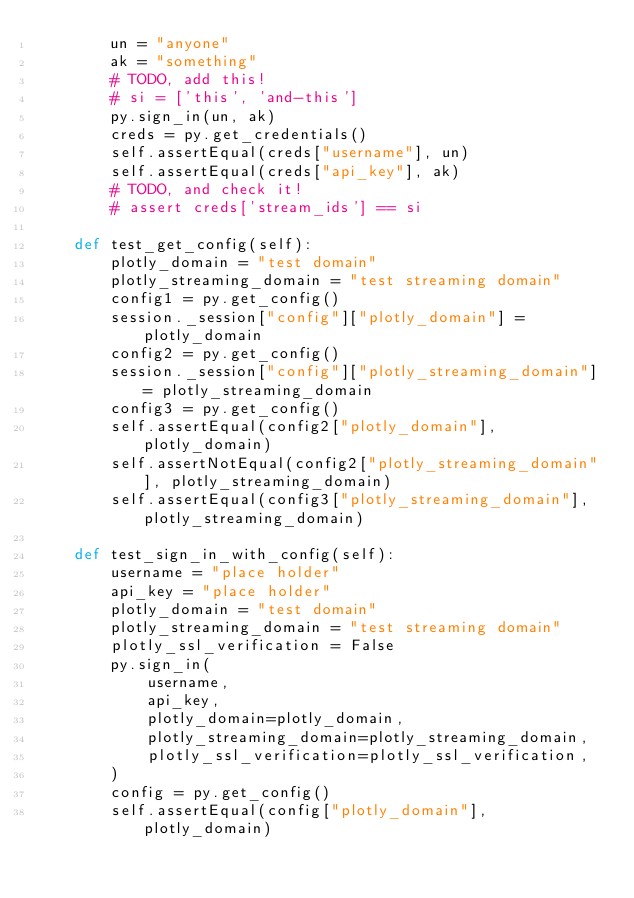<code> <loc_0><loc_0><loc_500><loc_500><_Python_>        un = "anyone"
        ak = "something"
        # TODO, add this!
        # si = ['this', 'and-this']
        py.sign_in(un, ak)
        creds = py.get_credentials()
        self.assertEqual(creds["username"], un)
        self.assertEqual(creds["api_key"], ak)
        # TODO, and check it!
        # assert creds['stream_ids'] == si

    def test_get_config(self):
        plotly_domain = "test domain"
        plotly_streaming_domain = "test streaming domain"
        config1 = py.get_config()
        session._session["config"]["plotly_domain"] = plotly_domain
        config2 = py.get_config()
        session._session["config"]["plotly_streaming_domain"] = plotly_streaming_domain
        config3 = py.get_config()
        self.assertEqual(config2["plotly_domain"], plotly_domain)
        self.assertNotEqual(config2["plotly_streaming_domain"], plotly_streaming_domain)
        self.assertEqual(config3["plotly_streaming_domain"], plotly_streaming_domain)

    def test_sign_in_with_config(self):
        username = "place holder"
        api_key = "place holder"
        plotly_domain = "test domain"
        plotly_streaming_domain = "test streaming domain"
        plotly_ssl_verification = False
        py.sign_in(
            username,
            api_key,
            plotly_domain=plotly_domain,
            plotly_streaming_domain=plotly_streaming_domain,
            plotly_ssl_verification=plotly_ssl_verification,
        )
        config = py.get_config()
        self.assertEqual(config["plotly_domain"], plotly_domain)</code> 